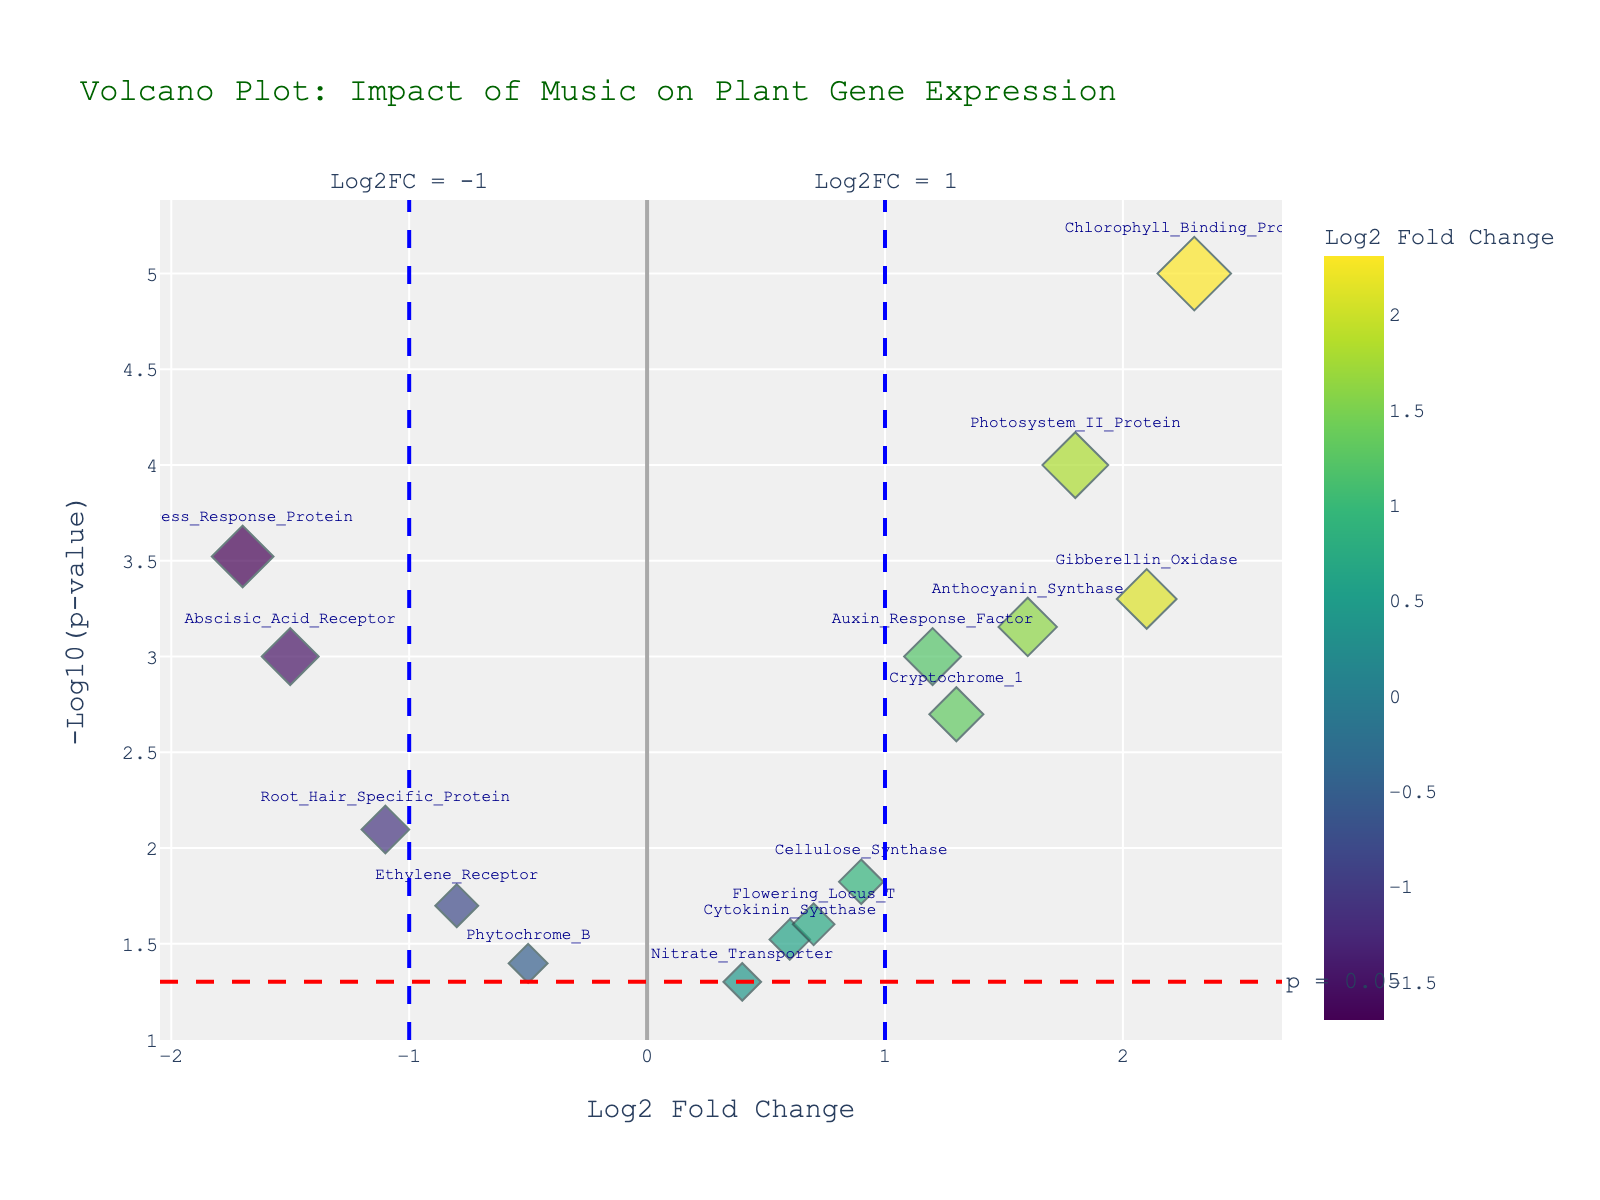What is the title of the plot? The title can be found at the top of the plot. Here, the title is "Volcano Plot: Impact of Music on Plant Gene Expression."
Answer: Volcano Plot: Impact of Music on Plant Gene Expression How many genes have a p-value less than 0.05? Genes with p-values less than 0.05 will be above the red dashed horizontal line at y = -log10(0.05). By counting, there are 13 such genes.
Answer: 13 Which gene has the highest log2 fold change and what is its p-value? The gene with the highest log2 fold change is the one that is farthest to the right on the x-axis. The highest log2 fold change is for Chlorophyll_Binding_Protein with a value of 2.3, and its p-value can be seen from the hover data near its marker, which is 0.00001.
Answer: Chlorophyll_Binding_Protein, 0.00001 What is the significance threshold line for p-values, and what does it indicate? The significance threshold line for p-values is the red dashed line at y = -log10(0.05). It indicates that genes above this line have p-values less than 0.05, which are considered statistically significant.
Answer: y = -log10(0.05), statistically significant Compare the genes Auxin_Response_Factor and Abscisic_Acid_Receptor in terms of log2 fold change and p-value. Auxin_Response_Factor has a log2 fold change of 1.2 and a p-value of 0.001, while Abscisic_Acid_Receptor has a log2 fold change of -1.5 and a p-value of 0.001. Auxin_Response_Factor shows a positive fold change indicating higher expression, whereas Abscisic_Acid_Receptor shows a negative fold change indicating lower expression under the influence of music. Both are considered statistically significant.
Answer: Auxin_Response_Factor: 1.2, 0.001; Abscisic_Acid_Receptor: -1.5, 0.001 Which gene has the smallest p-value and what is its -log10(p-value)? The gene with the smallest p-value will be the one highest on the y-axis. Chlorophyll_Binding_Protein has a p-value of 0.00001, and its -log10(p-value) is -log10(0.00001), which equals 5.
Answer: Chlorophyll_Binding_Protein, 5 What is the color of the markers, and what does it represent? The color of the markers ranges along a Viridis color scale from yellow to dark blue/green. The color represents the log2 fold change value, with different shades indicating different levels of gene expression changes.
Answer: Represents log2 fold change value Identify a gene with a negative log2 fold change and low p-value. Stress_Response_Protein has a log2 fold change of -1.7 and a p-value of 0.0003, which is both negative and statistically significant.
Answer: Stress_Response_Protein How many genes have both To find this, count genes above the red dashed line indicating p-values less than 0.05 and outside the blue vertical dashed lines indicating log2 fold change between −1 and 1. 9 genes meet these criteria as they lie outside these thresholds.
Answer: 9 